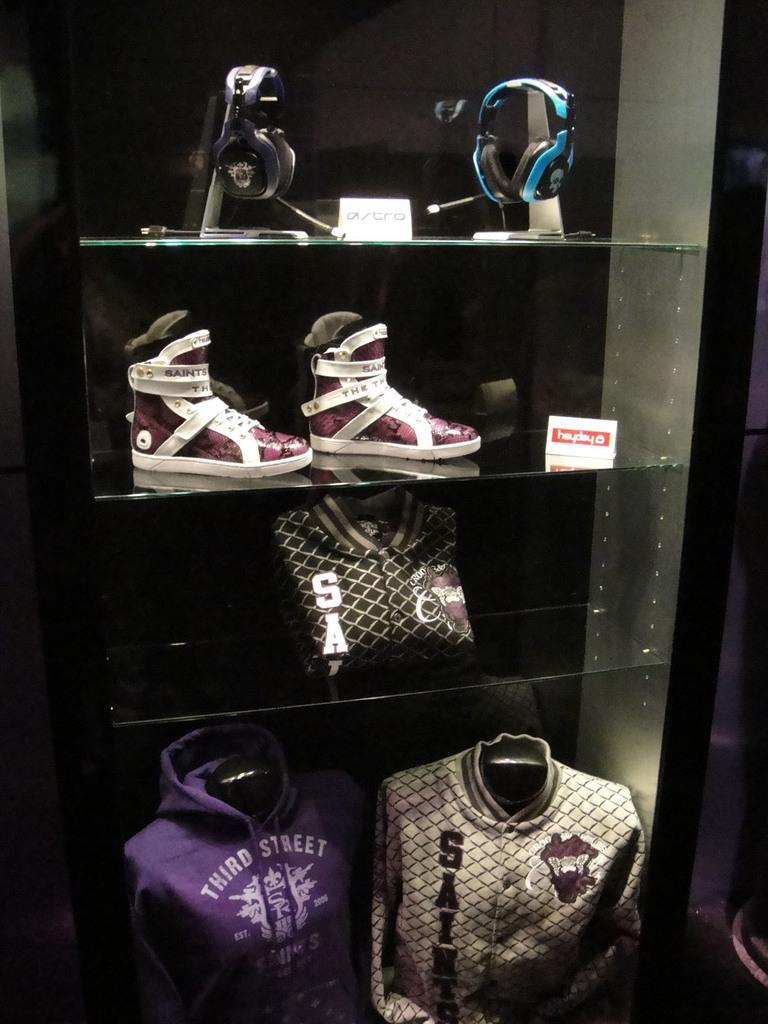How would you summarize this image in a sentence or two? In this image there are glass shelves. At the top there are earphones. Below it there are shoes. At the bottom there are dresses kept in the shelves. 